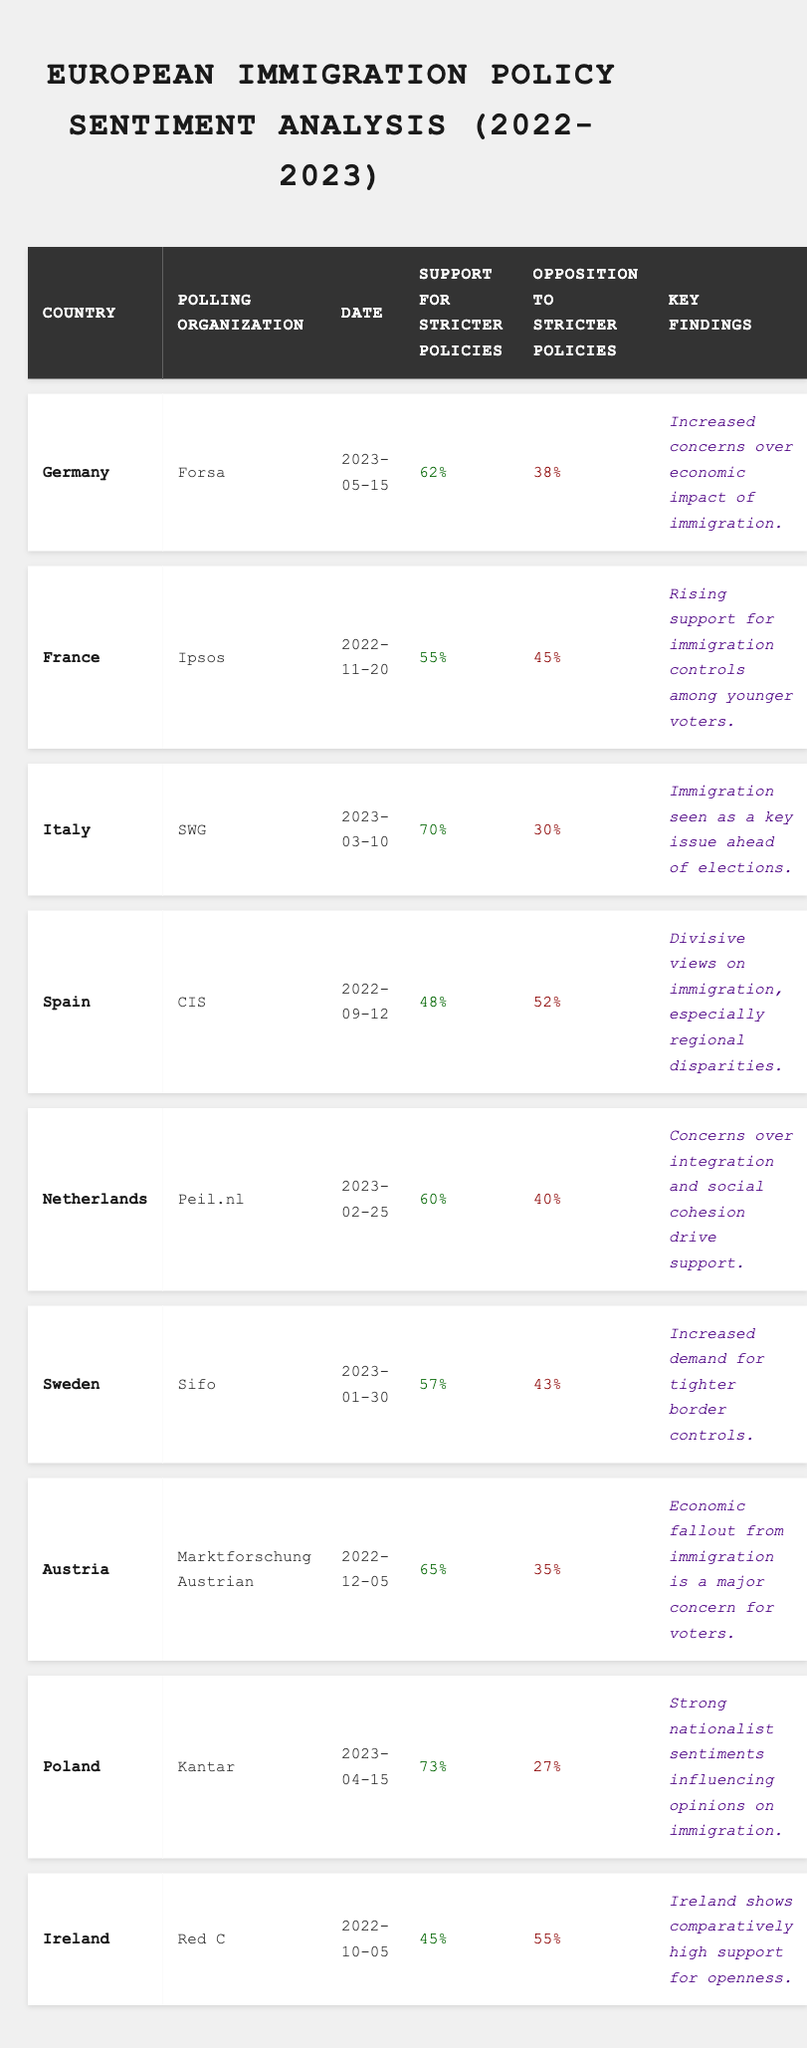What is the date of the Forsa poll in Germany? The table lists the polling organization Forsa under Germany and shows the date as 2023-05-15.
Answer: 2023-05-15 Which country has the highest support for stricter immigration policies? Poland has the highest support at 73%, as indicated in the table.
Answer: Poland What percentage of respondents in France opposed stricter immigration policies? The table shows that 45% of respondents in France, conducted by Ipsos, opposed stricter immigration policies.
Answer: 45% How much higher is support for stricter immigration policies in Italy compared to Germany? Italy's support is 70% and Germany's is 62%. The difference is 70% - 62% = 8%.
Answer: 8% Which country showed the least support for stricter immigration policies in the data? Ireland has the least support at 45%, as shown in the table.
Answer: Ireland Is there a majority in Spain in favor of stricter immigration policies? The table indicates that 48% support stricter policies and 52% oppose them, meaning there is no majority in favor.
Answer: No Calculate the average support for stricter immigration policies across the listed countries. To find the average, add all support percentages: (62 + 55 + 70 + 48 + 60 + 57 + 65 + 73 + 45) = 605. There are 9 countries, so 605/9 = 67.22.
Answer: 67.22 Which polling organization conducted the poll in Sweden? The table lists the polling organization for Sweden as Sifo.
Answer: Sifo What does the key finding for Poland indicate about public sentiment regarding immigration? The key finding in Poland notes strong nationalist sentiments influencing opinions on immigration.
Answer: Strong nationalism In how many countries is there greater opposition than support for stricter immigration policies? The table shows that only Ireland (55% oppose) and Spain (52% oppose) have greater opposition than support, totaling 2 countries.
Answer: 2 